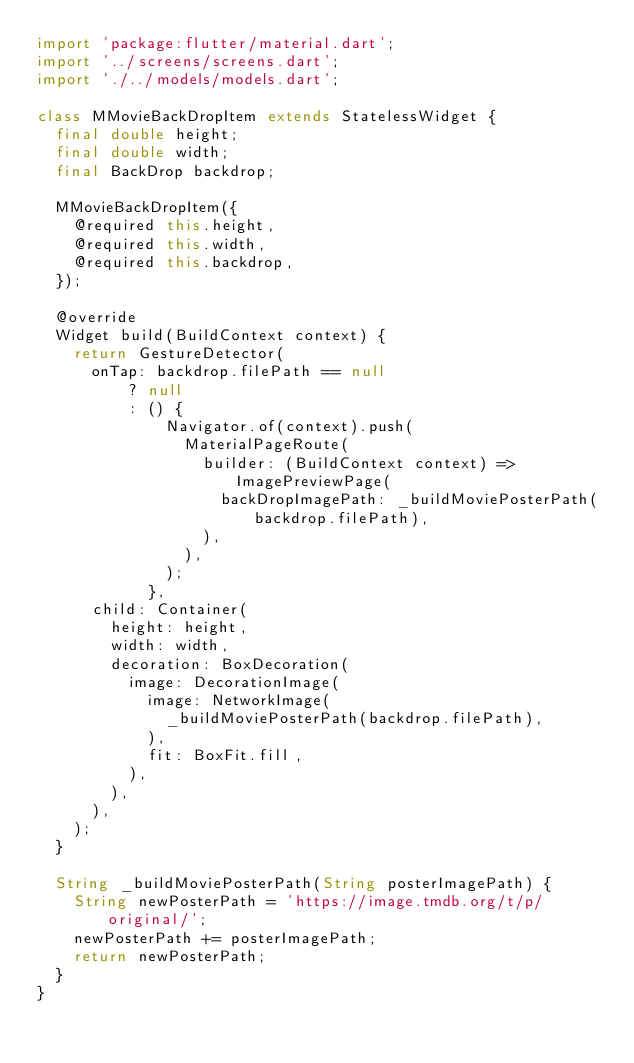<code> <loc_0><loc_0><loc_500><loc_500><_Dart_>import 'package:flutter/material.dart';
import '../screens/screens.dart';
import './../models/models.dart';

class MMovieBackDropItem extends StatelessWidget {
  final double height;
  final double width;
  final BackDrop backdrop;

  MMovieBackDropItem({
    @required this.height,
    @required this.width,
    @required this.backdrop,
  });

  @override
  Widget build(BuildContext context) {
    return GestureDetector(
      onTap: backdrop.filePath == null
          ? null
          : () {
              Navigator.of(context).push(
                MaterialPageRoute(
                  builder: (BuildContext context) => ImagePreviewPage(
                    backDropImagePath: _buildMoviePosterPath(backdrop.filePath),
                  ),
                ),
              );
            },
      child: Container(
        height: height,
        width: width,
        decoration: BoxDecoration(
          image: DecorationImage(
            image: NetworkImage(
              _buildMoviePosterPath(backdrop.filePath),
            ),
            fit: BoxFit.fill,
          ),
        ),
      ),
    );
  }

  String _buildMoviePosterPath(String posterImagePath) {
    String newPosterPath = 'https://image.tmdb.org/t/p/original/';
    newPosterPath += posterImagePath;
    return newPosterPath;
  }
}
</code> 